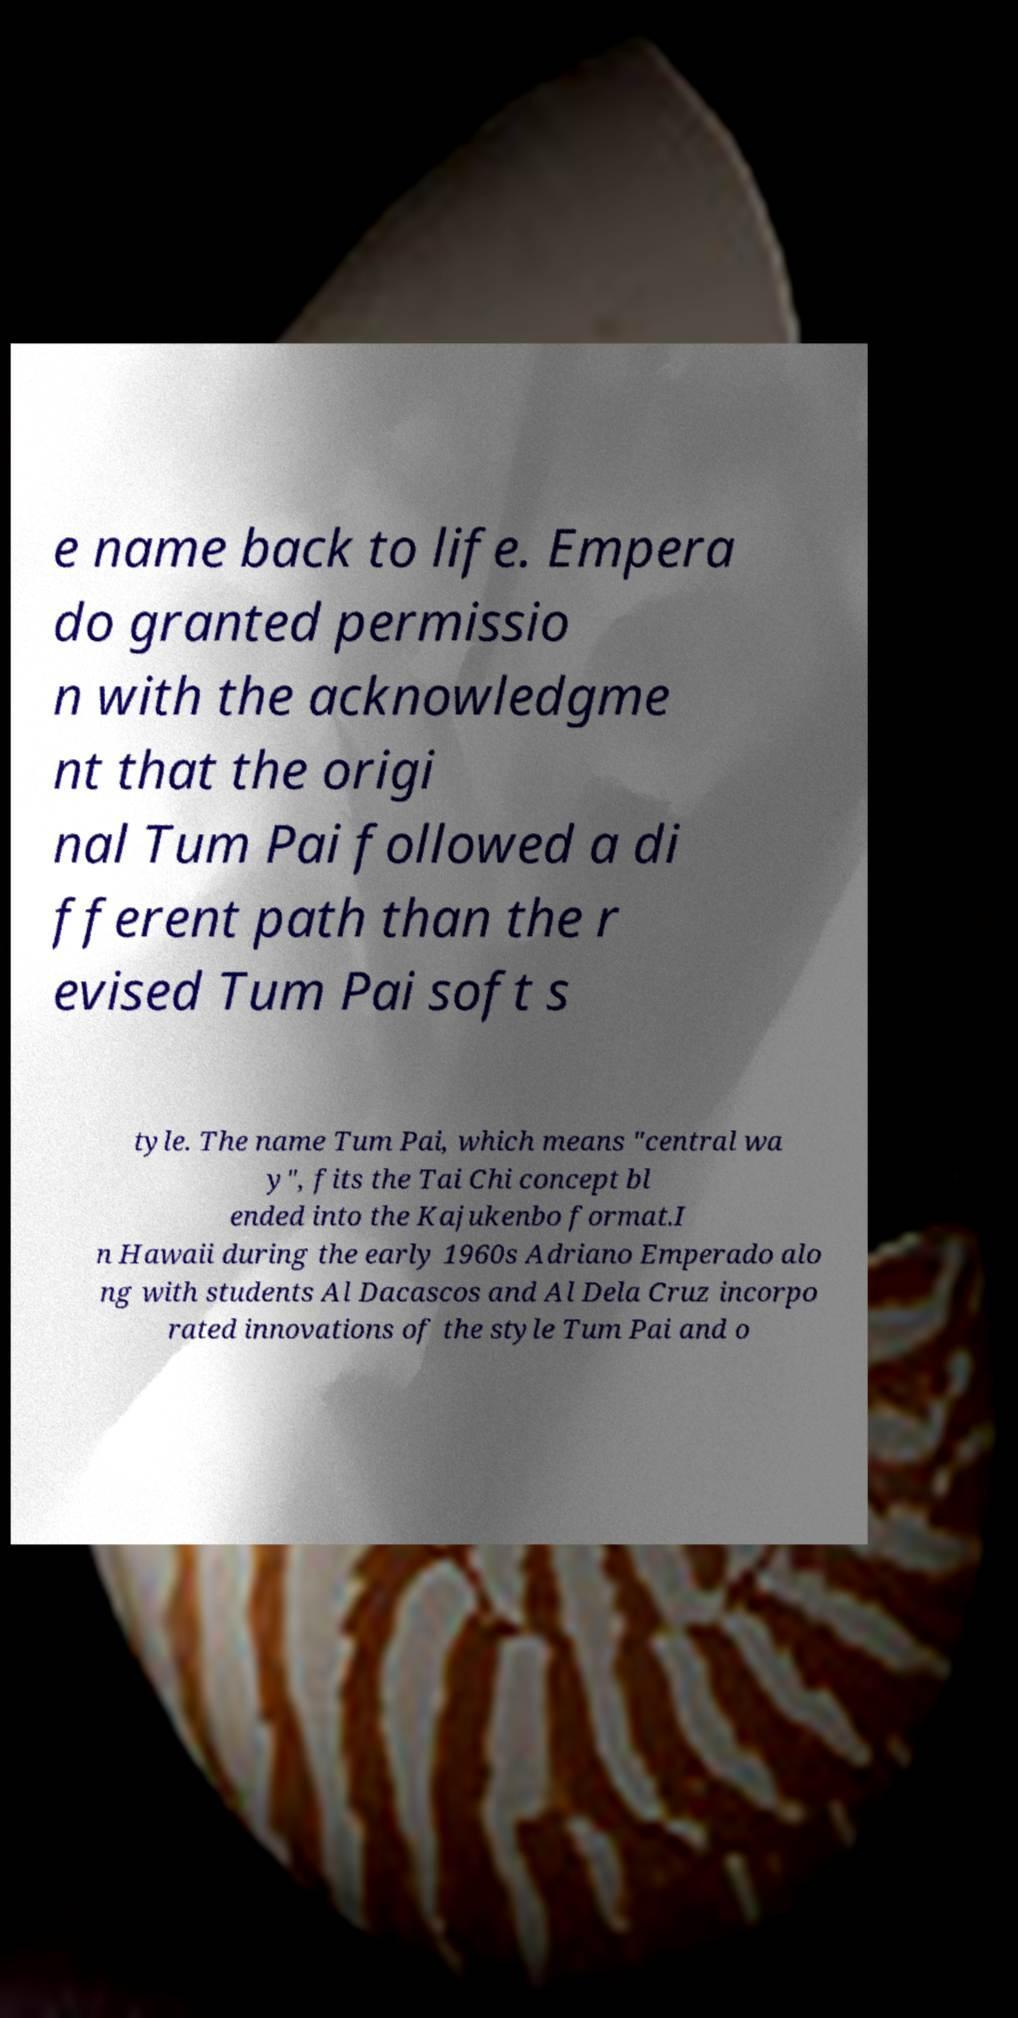For documentation purposes, I need the text within this image transcribed. Could you provide that? e name back to life. Empera do granted permissio n with the acknowledgme nt that the origi nal Tum Pai followed a di fferent path than the r evised Tum Pai soft s tyle. The name Tum Pai, which means "central wa y", fits the Tai Chi concept bl ended into the Kajukenbo format.I n Hawaii during the early 1960s Adriano Emperado alo ng with students Al Dacascos and Al Dela Cruz incorpo rated innovations of the style Tum Pai and o 